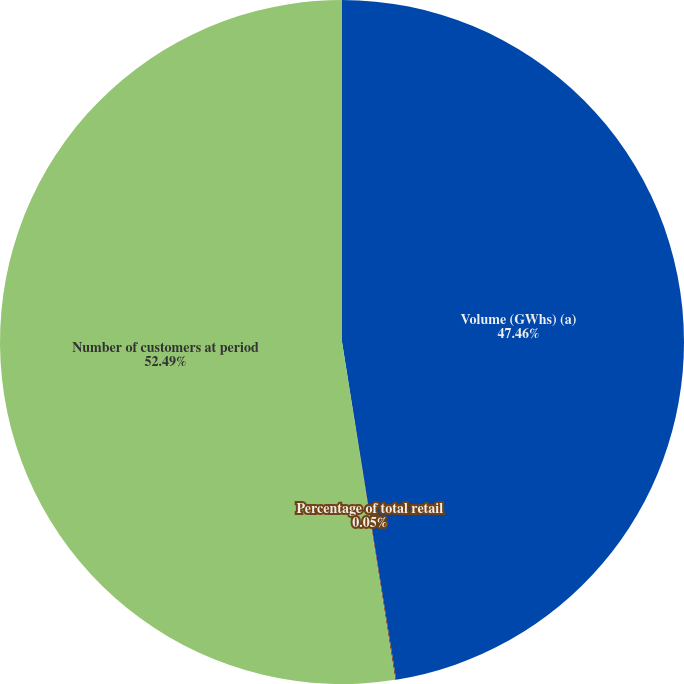Convert chart to OTSL. <chart><loc_0><loc_0><loc_500><loc_500><pie_chart><fcel>Volume (GWhs) (a)<fcel>Percentage of total retail<fcel>Number of customers at period<nl><fcel>47.46%<fcel>0.05%<fcel>52.48%<nl></chart> 